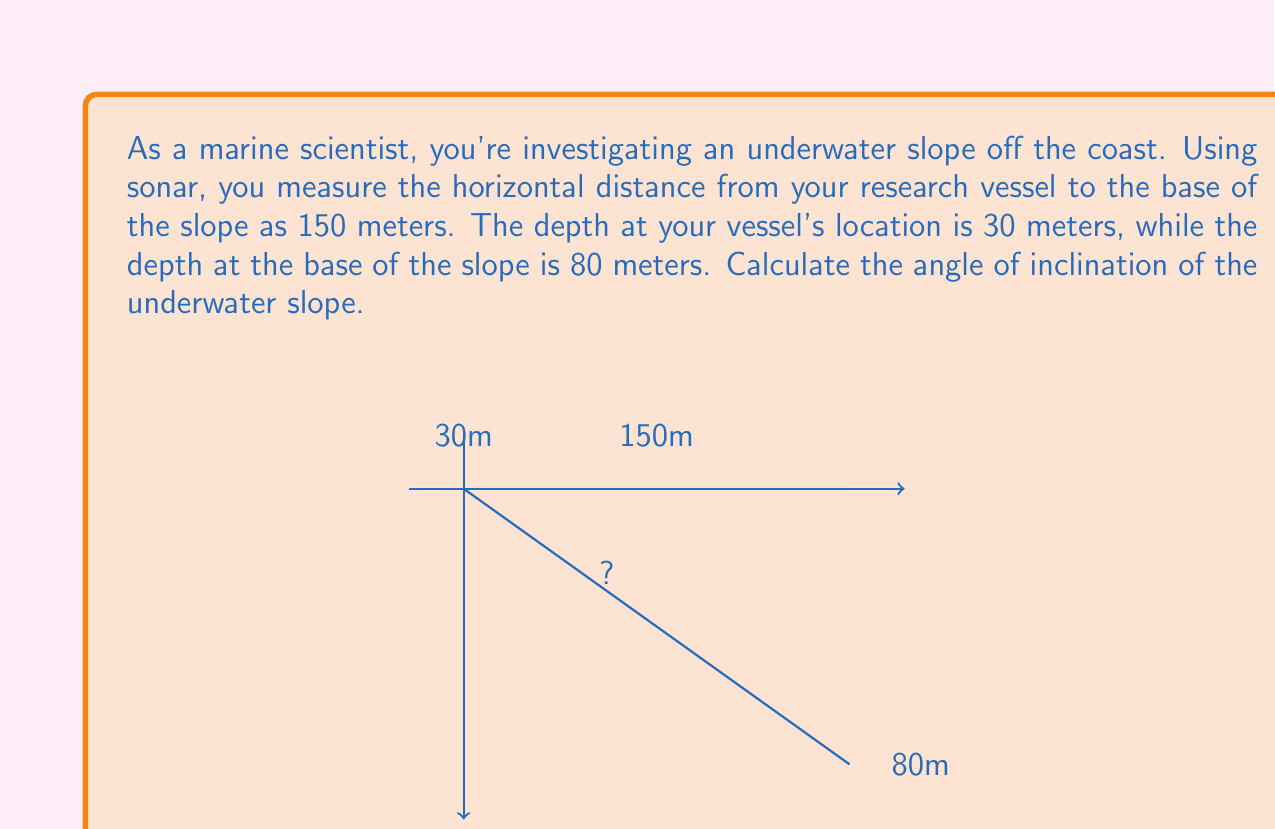Can you solve this math problem? To solve this problem, we'll follow these steps:

1) First, let's identify the right triangle formed by the vessel, the base of the slope, and the water surface.

2) We need to find the difference in depth between the vessel and the base of the slope:
   $80m - 30m = 50m$

3) Now we have a right triangle where:
   - The adjacent side (horizontal distance) is 150m
   - The opposite side (depth difference) is 50m

4) To find the angle of inclination, we need to use the tangent function:

   $\tan(\theta) = \frac{\text{opposite}}{\text{adjacent}} = \frac{50}{150}$

5) To get the angle, we need to take the inverse tangent (arctan or $\tan^{-1}$):

   $\theta = \tan^{-1}(\frac{50}{150})$

6) Simplifying the fraction:

   $\theta = \tan^{-1}(\frac{1}{3})$

7) Using a calculator or trigonometric tables:

   $\theta \approx 18.43°$

Therefore, the angle of inclination of the underwater slope is approximately 18.43°.
Answer: $18.43°$ 